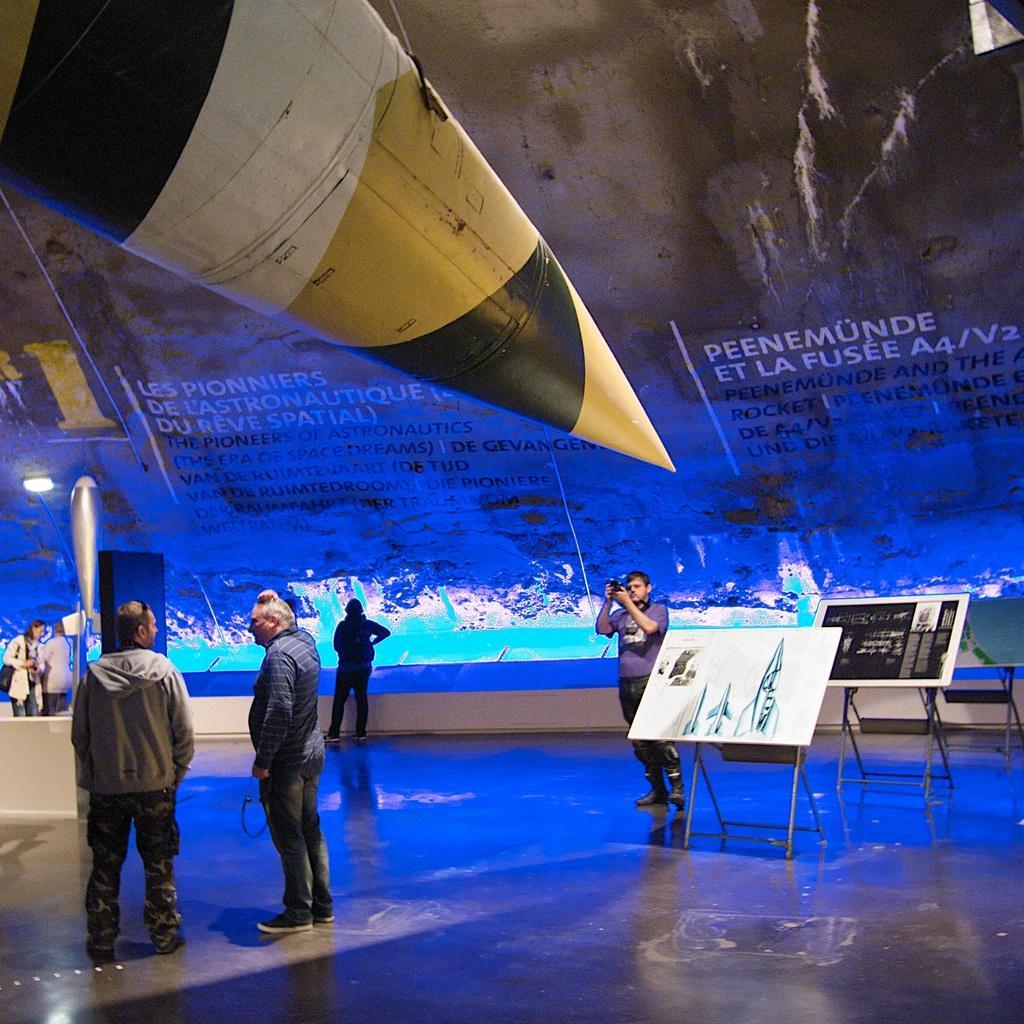Describe this image in one or two sentences. In this image there are group of people and some boards, in the center there is one person who is holding a camera. At the bottom there is floor, and on the left side there is some object. And in the background there are some boards, lights and some objects. On the boards there is text. 